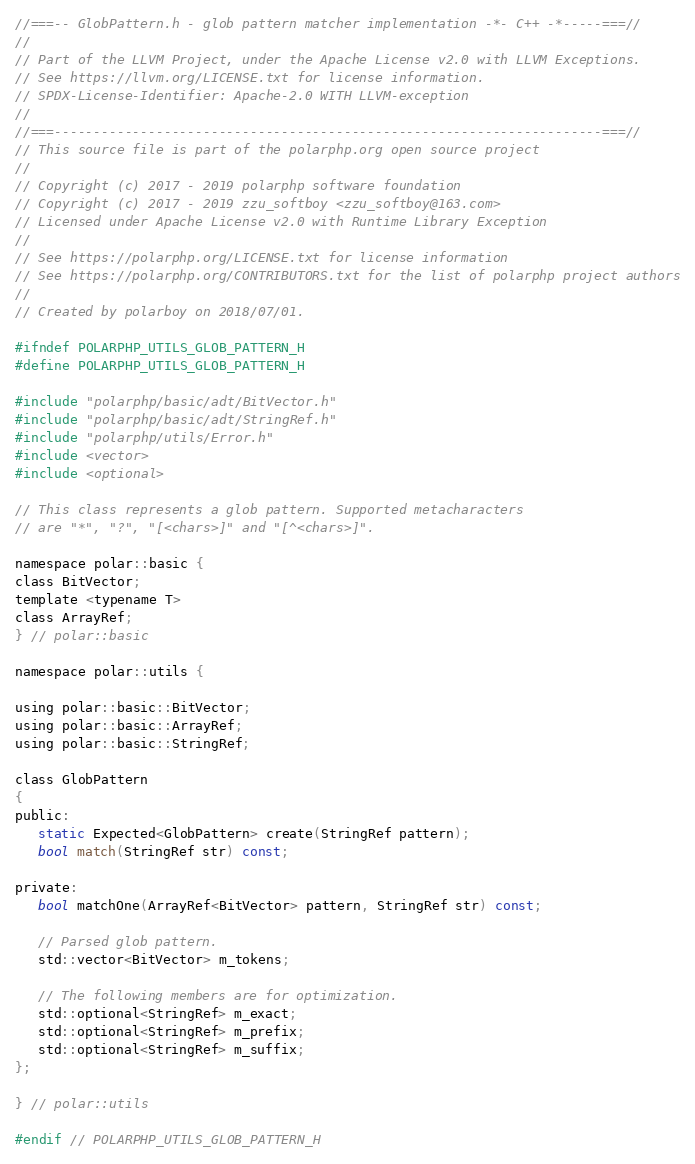<code> <loc_0><loc_0><loc_500><loc_500><_C_>//===-- GlobPattern.h - glob pattern matcher implementation -*- C++ -*-----===//
//
// Part of the LLVM Project, under the Apache License v2.0 with LLVM Exceptions.
// See https://llvm.org/LICENSE.txt for license information.
// SPDX-License-Identifier: Apache-2.0 WITH LLVM-exception
//
//===----------------------------------------------------------------------===//
// This source file is part of the polarphp.org open source project
//
// Copyright (c) 2017 - 2019 polarphp software foundation
// Copyright (c) 2017 - 2019 zzu_softboy <zzu_softboy@163.com>
// Licensed under Apache License v2.0 with Runtime Library Exception
//
// See https://polarphp.org/LICENSE.txt for license information
// See https://polarphp.org/CONTRIBUTORS.txt for the list of polarphp project authors
//
// Created by polarboy on 2018/07/01.

#ifndef POLARPHP_UTILS_GLOB_PATTERN_H
#define POLARPHP_UTILS_GLOB_PATTERN_H

#include "polarphp/basic/adt/BitVector.h"
#include "polarphp/basic/adt/StringRef.h"
#include "polarphp/utils/Error.h"
#include <vector>
#include <optional>

// This class represents a glob pattern. Supported metacharacters
// are "*", "?", "[<chars>]" and "[^<chars>]".

namespace polar::basic {
class BitVector;
template <typename T>
class ArrayRef;
} // polar::basic

namespace polar::utils {

using polar::basic::BitVector;
using polar::basic::ArrayRef;
using polar::basic::StringRef;

class GlobPattern
{
public:
   static Expected<GlobPattern> create(StringRef pattern);
   bool match(StringRef str) const;

private:
   bool matchOne(ArrayRef<BitVector> pattern, StringRef str) const;

   // Parsed glob pattern.
   std::vector<BitVector> m_tokens;

   // The following members are for optimization.
   std::optional<StringRef> m_exact;
   std::optional<StringRef> m_prefix;
   std::optional<StringRef> m_suffix;
};

} // polar::utils

#endif // POLARPHP_UTILS_GLOB_PATTERN_H
</code> 